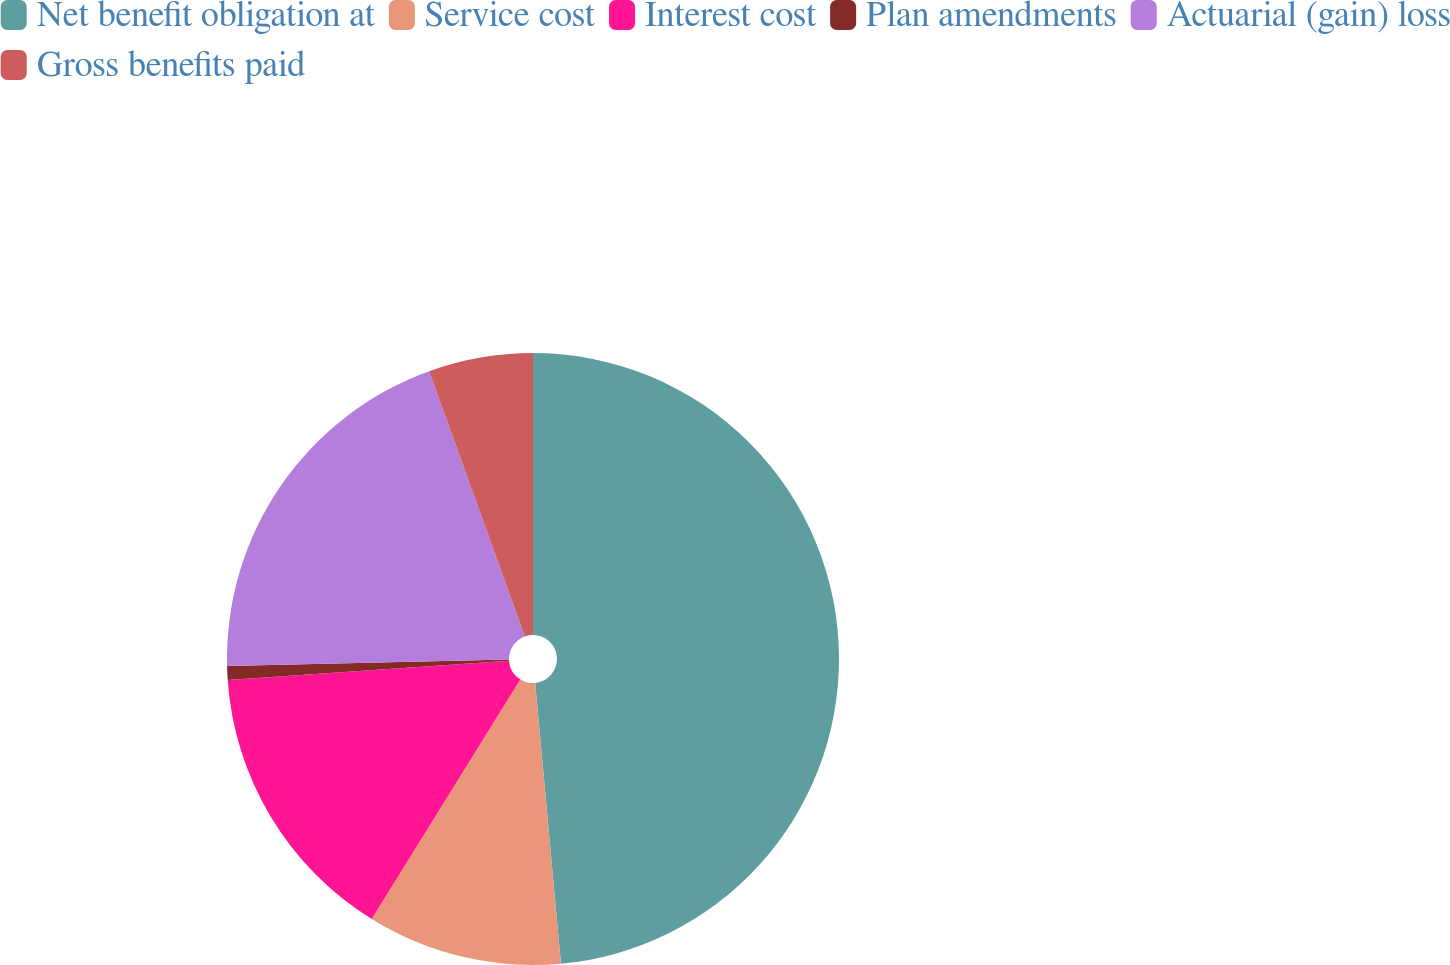Convert chart to OTSL. <chart><loc_0><loc_0><loc_500><loc_500><pie_chart><fcel>Net benefit obligation at<fcel>Service cost<fcel>Interest cost<fcel>Plan amendments<fcel>Actuarial (gain) loss<fcel>Gross benefits paid<nl><fcel>48.54%<fcel>10.29%<fcel>15.07%<fcel>0.73%<fcel>19.85%<fcel>5.51%<nl></chart> 